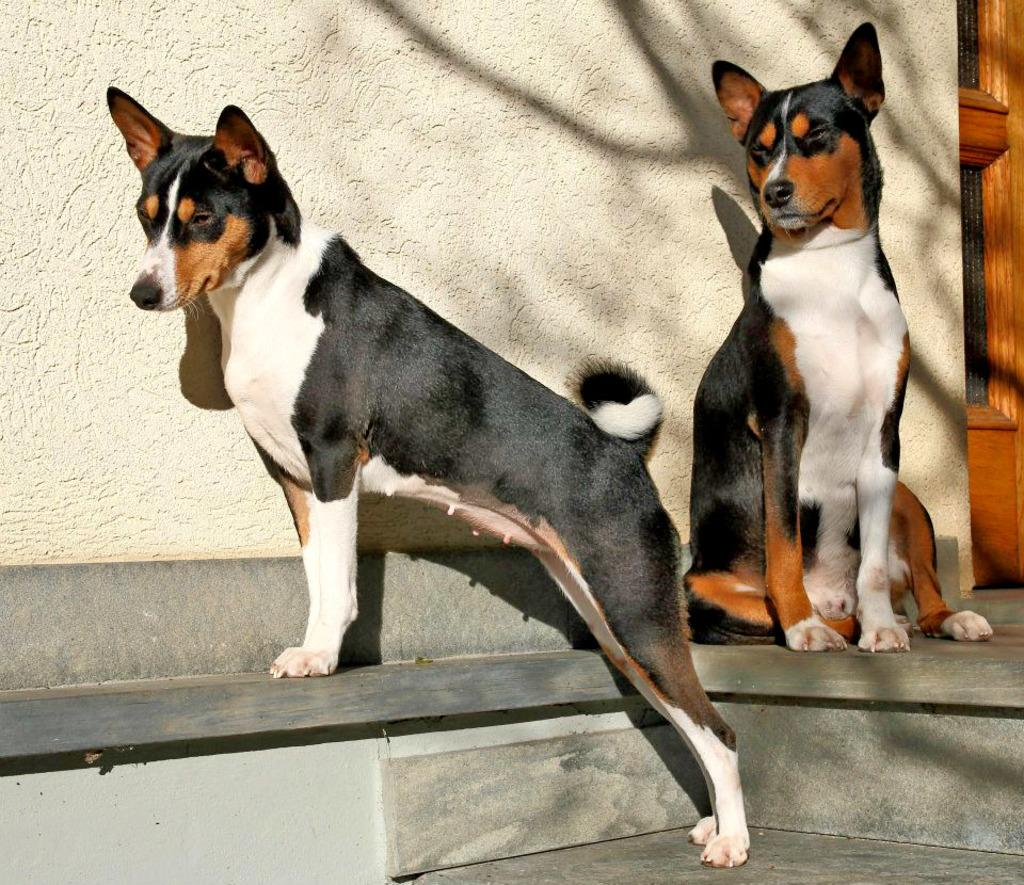What types of living organisms can be seen in the image? There are animals in the image. What structure is visible in the image? There is a house in the image. Where is the door located in the image? The door is on the right side of the image. What flavor of lip balm is the cat using in the image? There is no cat or lip balm present in the image. 